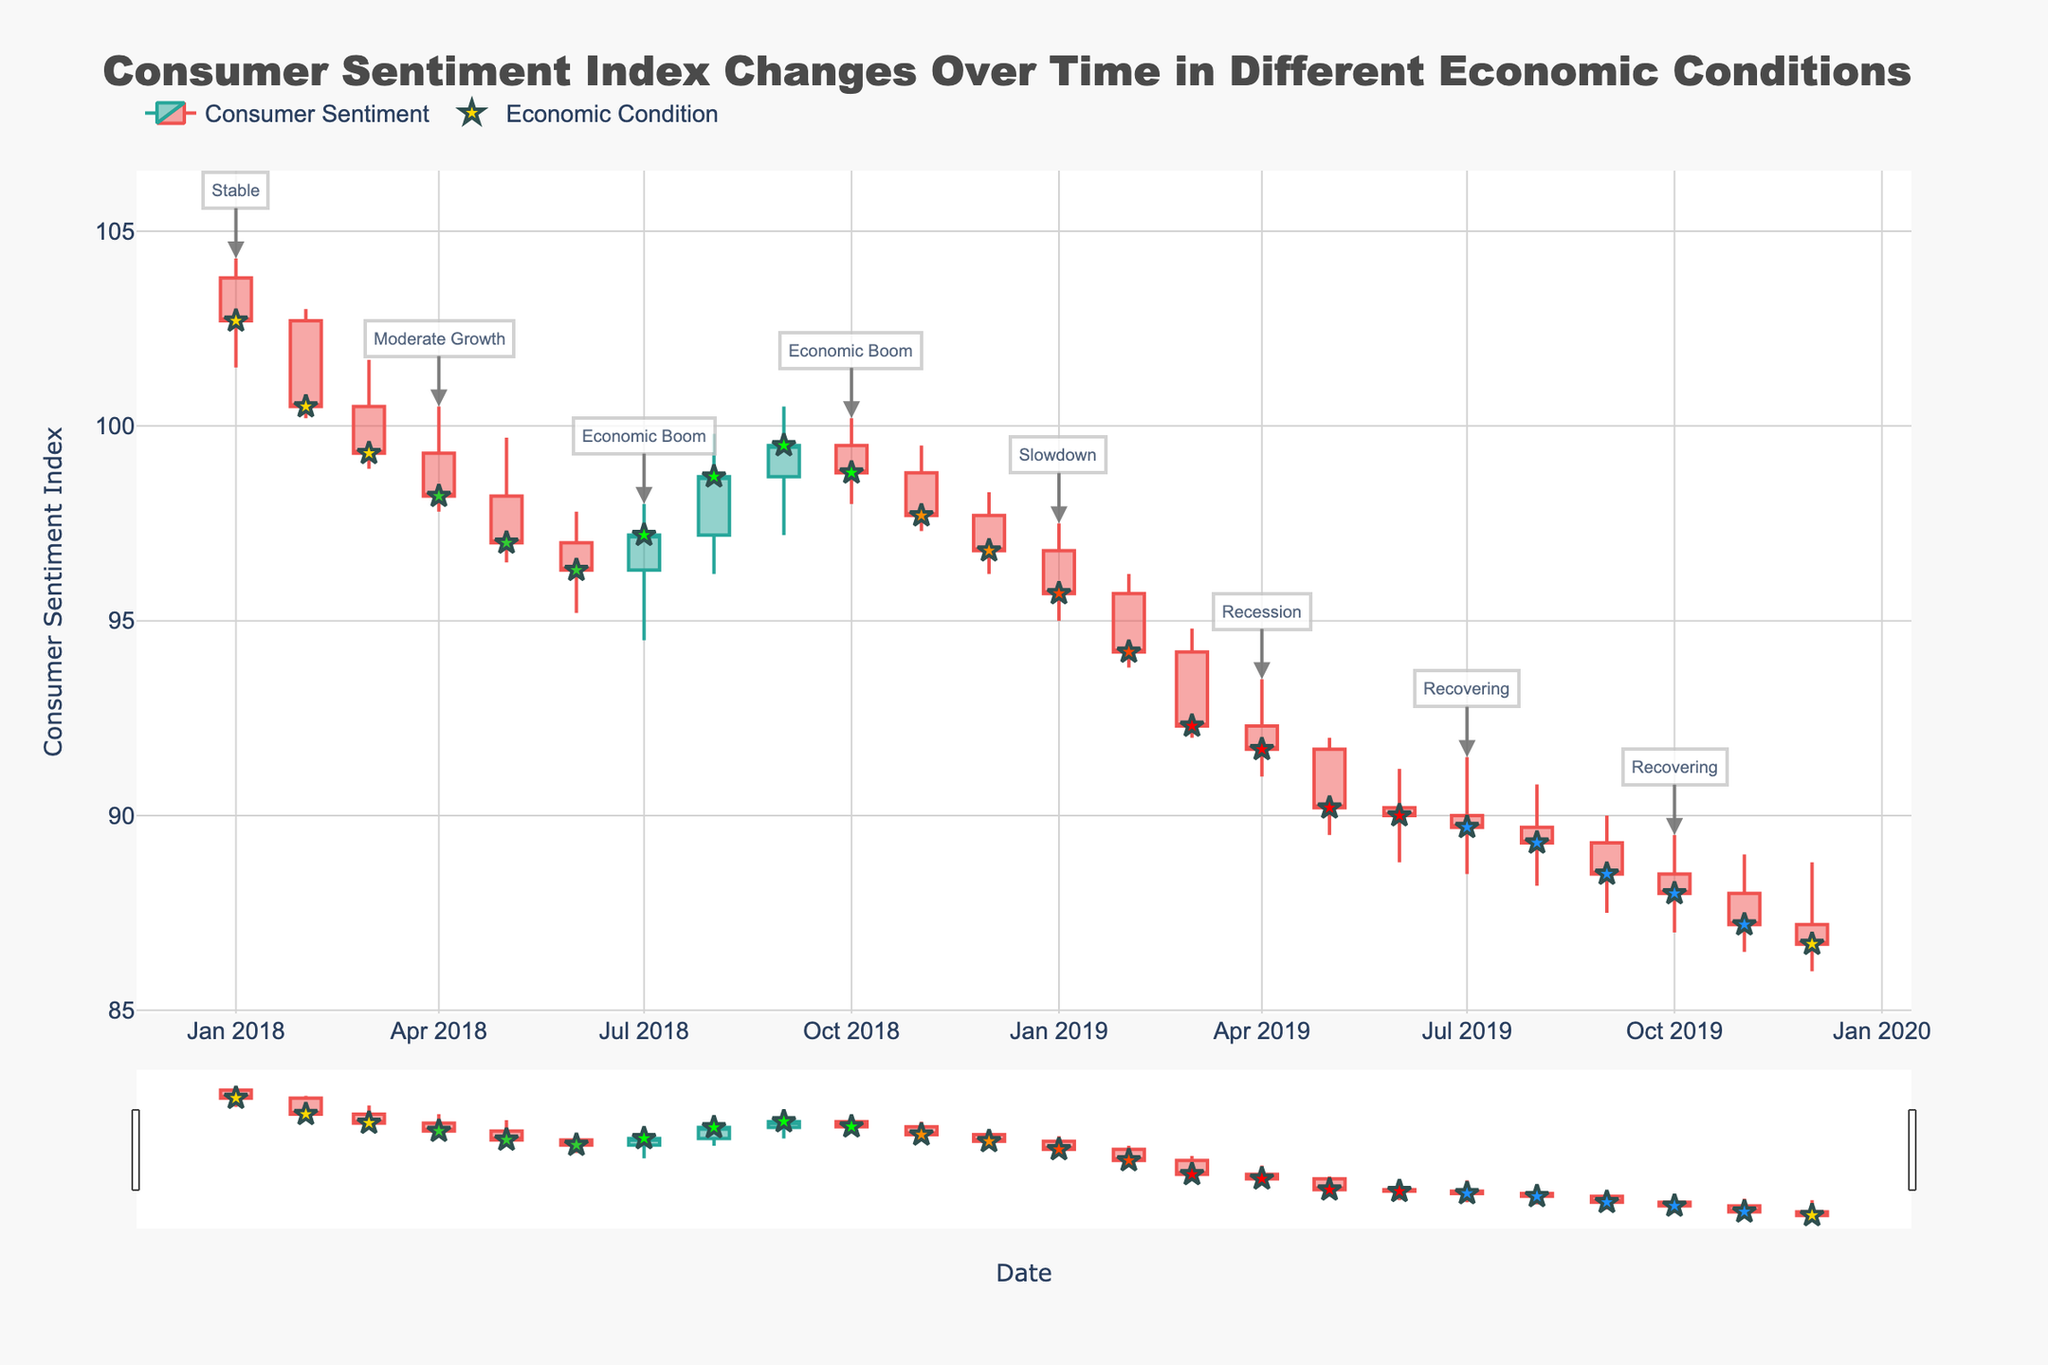What is the title of the plot? The title of the plot is displayed prominently at the top of the figure and can be found by reading this text.
Answer: Consumer Sentiment Index Changes Over Time in Different Economic Conditions What are the highest and lowest values of the Consumer Sentiment Index in the dataset? By examining the highest and lowest points on the y-axis (Consumer Sentiment Index), along with the corresponding highest and lowest candlesticks, you can determine these values. The highest value is around 104.3 and the lowest is around 86
Answer: Highest: 104.3, Lowest: 86 Which economic condition corresponds with the highest Consumer Sentiment Index? By identifying the highest candlestick (104.3) and checking the annotation or colored marker associated with it, you can see this corresponds to the 'Stable' condition in January 2018.
Answer: Stable How did the Consumer Sentiment Index change during the "Economic Boom" period? The "Economic Boom" period is indicated by the green markers on the chart. By observing the candlestick patterns during this period, you can see how the index changed from the start to the end of this period. It started around 96.3 in July 2018 and rose to around 98.8 in October 2018 before slightly dropping to the 97-99 range.
Answer: It gradually increased Which economic condition immediately follows the "Recession" period? By looking at the annotations or colored markers on the chart just after the red markers of the "Recession" period, the next condition, marked in blue, is "Recovering".
Answer: Recovering How does the closing value in July 2018 (Economic Boom) compare with the closing value in July 2019 (Recovering)? By checking the closing values for the two specified months, you can see if one is greater or lesser than the other. July 2018 has a closing value of 97.2 and July 2019 has a closing value of 89.7.
Answer: 97.2 is greater than 89.7 What is the trend of the Consumer Sentiment Index during the "Slowdown" period? By examining the candlestick patterns from January 2019 to February 2019, the markers for this period, you can determine if the index is generally increasing, decreasing, or stable.
Answer: Decreasing In which months did the Consumer Sentiment Index experience the greatest volatility? Volatility can be judged by large differences between the high and low values in the candlesticks. By comparing the lengths of the candlesticks, February 2019 and March 2019 show the greatest volatility.
Answer: February and March 2019 What is the difference in the closing value from the beginning to the end of the "Stable" period in 2018? The "Stable" condition in 2018 is from Jan to Mar. The closing value in Jan is 102.7 and in Mar is 99.3. Subtracting the closing value of Jan from Mar gives the difference. 99.3 - 102.7 = -3.4
Answer: -3.4 